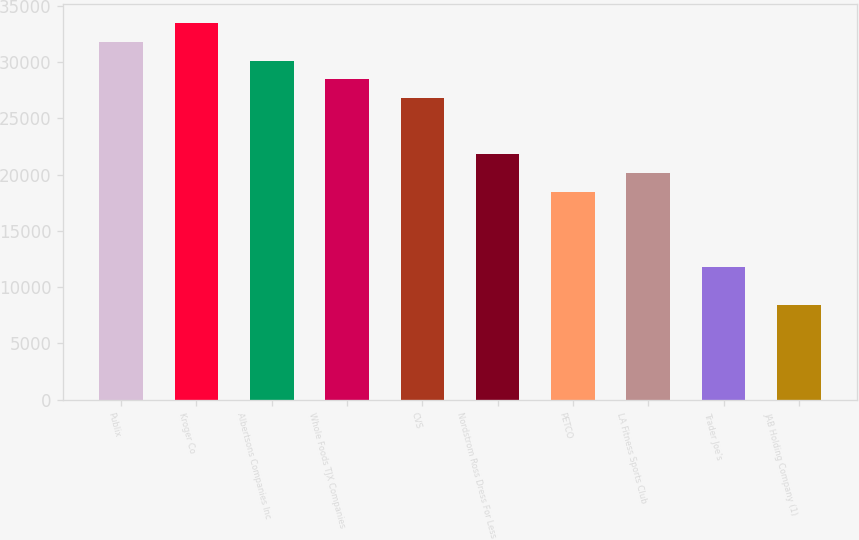Convert chart to OTSL. <chart><loc_0><loc_0><loc_500><loc_500><bar_chart><fcel>Publix<fcel>Kroger Co<fcel>Albertsons Companies Inc<fcel>Whole Foods TJX Companies<fcel>CVS<fcel>Nordstrom Ross Dress For Less<fcel>PETCO<fcel>LA Fitness Sports Club<fcel>Trader Joe's<fcel>JAB Holding Company (1)<nl><fcel>31792.4<fcel>33460<fcel>30124.8<fcel>28457.2<fcel>26789.6<fcel>21786.8<fcel>18451.6<fcel>20119.2<fcel>11781.2<fcel>8446<nl></chart> 